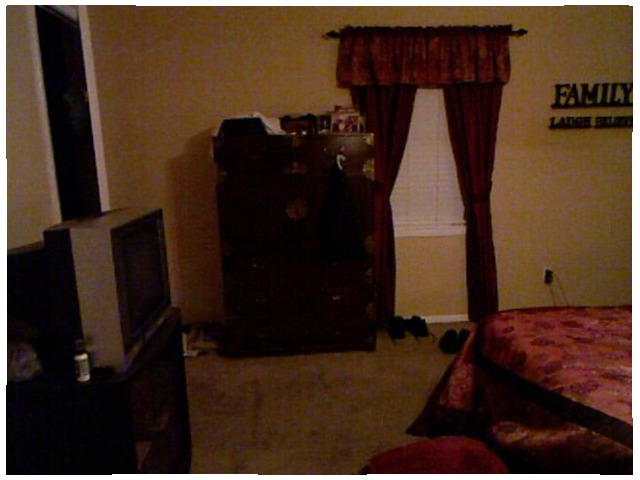<image>
Can you confirm if the curtains is above the bed? No. The curtains is not positioned above the bed. The vertical arrangement shows a different relationship. 